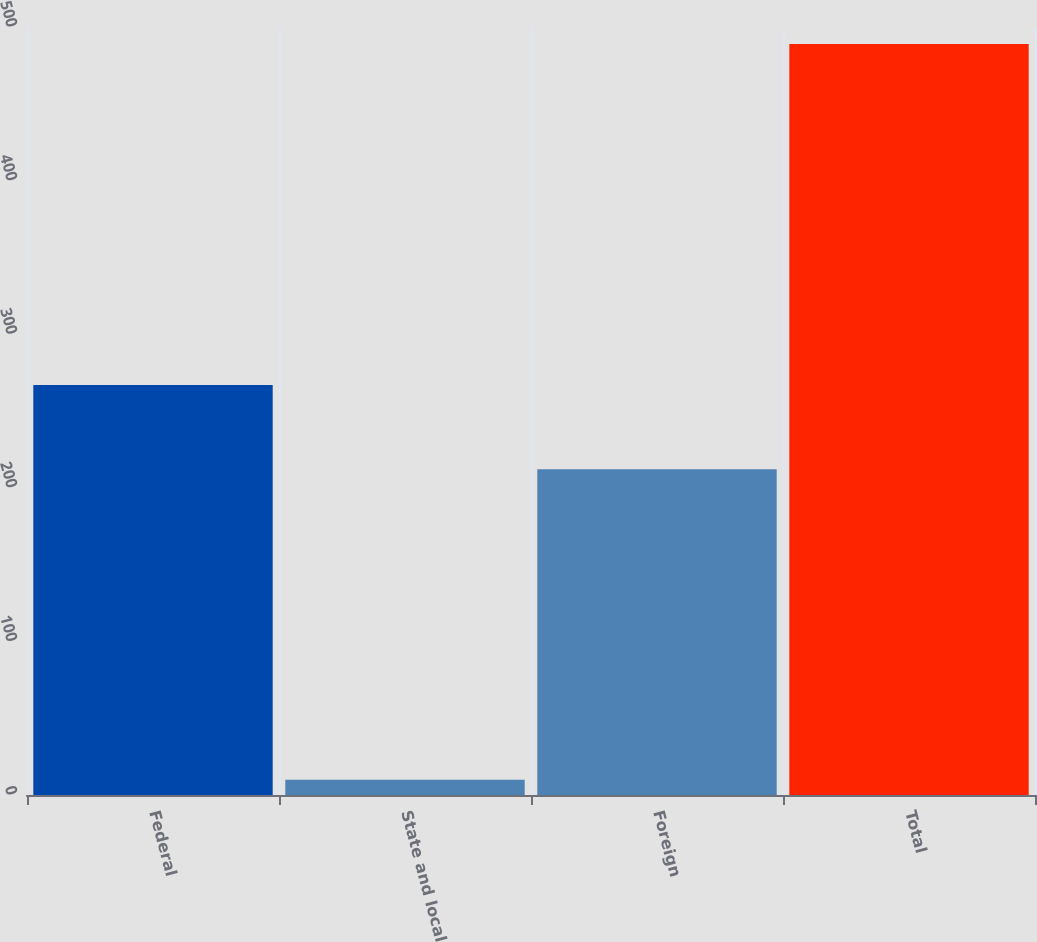Convert chart. <chart><loc_0><loc_0><loc_500><loc_500><bar_chart><fcel>Federal<fcel>State and local<fcel>Foreign<fcel>Total<nl><fcel>267<fcel>10<fcel>212<fcel>489<nl></chart> 